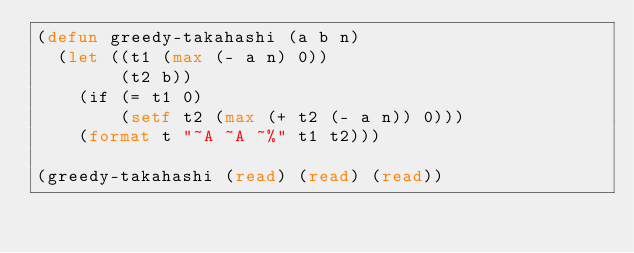Convert code to text. <code><loc_0><loc_0><loc_500><loc_500><_Lisp_>(defun greedy-takahashi (a b n)
  (let ((t1 (max (- a n) 0))
        (t2 b))
    (if (= t1 0)
        (setf t2 (max (+ t2 (- a n)) 0)))
    (format t "~A ~A ~%" t1 t2)))

(greedy-takahashi (read) (read) (read))</code> 